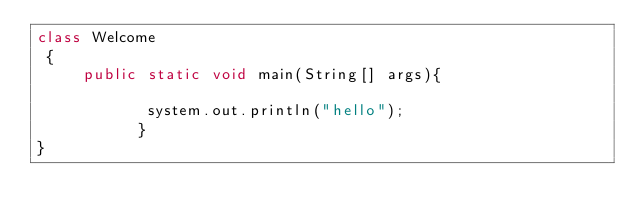Convert code to text. <code><loc_0><loc_0><loc_500><loc_500><_Java_>class Welcome
 {
     public static void main(String[] args){
         
            system.out.println("hello");
           }
}</code> 